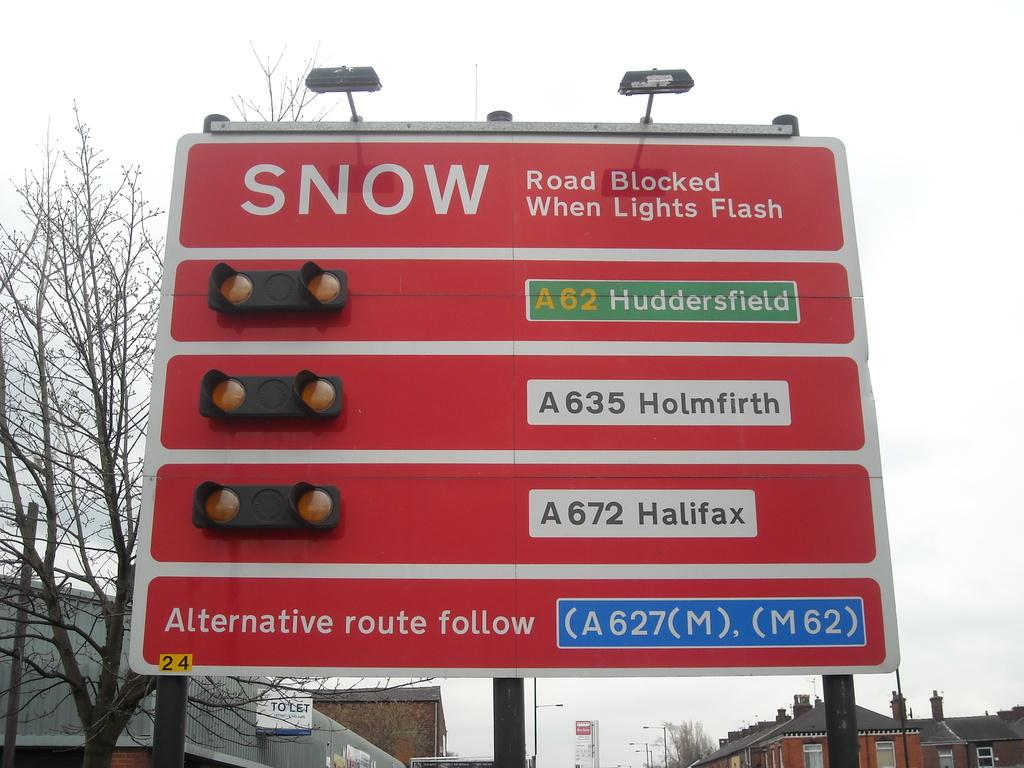<image>
Write a terse but informative summary of the picture. a red and white sign with the word snow on it 